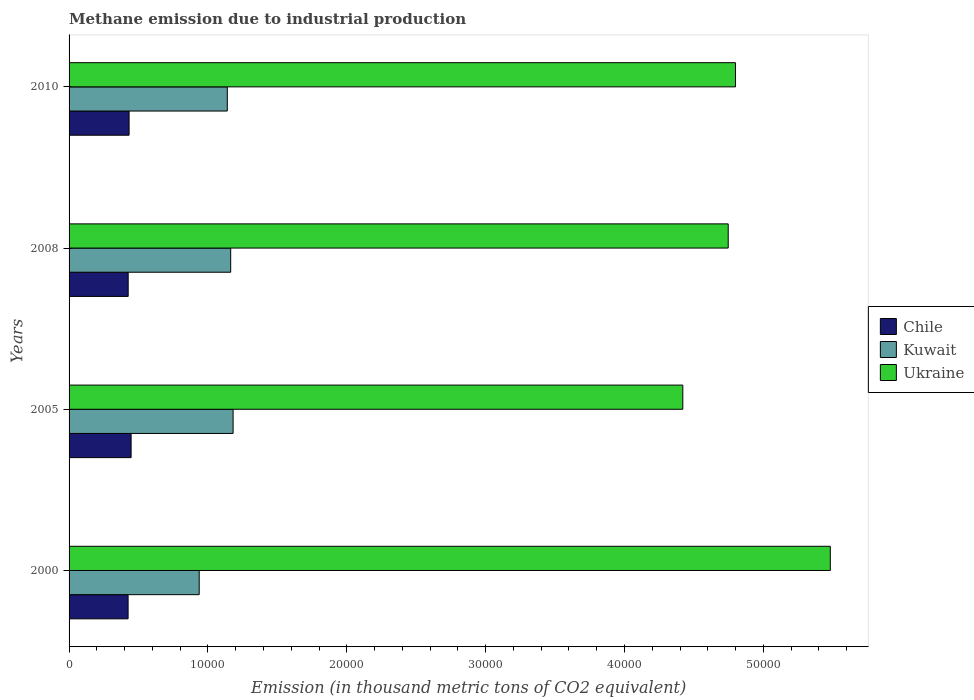How many different coloured bars are there?
Your response must be concise. 3. Are the number of bars per tick equal to the number of legend labels?
Ensure brevity in your answer.  Yes. How many bars are there on the 2nd tick from the top?
Your answer should be compact. 3. How many bars are there on the 2nd tick from the bottom?
Your response must be concise. 3. What is the label of the 4th group of bars from the top?
Offer a very short reply. 2000. In how many cases, is the number of bars for a given year not equal to the number of legend labels?
Offer a very short reply. 0. What is the amount of methane emitted in Ukraine in 2010?
Provide a succinct answer. 4.80e+04. Across all years, what is the maximum amount of methane emitted in Kuwait?
Give a very brief answer. 1.18e+04. Across all years, what is the minimum amount of methane emitted in Chile?
Your response must be concise. 4250.2. What is the total amount of methane emitted in Kuwait in the graph?
Your answer should be compact. 4.42e+04. What is the difference between the amount of methane emitted in Chile in 2005 and that in 2008?
Your response must be concise. 211. What is the difference between the amount of methane emitted in Kuwait in 2000 and the amount of methane emitted in Chile in 2008?
Offer a terse response. 5115. What is the average amount of methane emitted in Chile per year?
Provide a short and direct response. 4324.52. In the year 2010, what is the difference between the amount of methane emitted in Chile and amount of methane emitted in Ukraine?
Offer a very short reply. -4.37e+04. In how many years, is the amount of methane emitted in Chile greater than 48000 thousand metric tons?
Your answer should be very brief. 0. What is the ratio of the amount of methane emitted in Ukraine in 2005 to that in 2008?
Keep it short and to the point. 0.93. What is the difference between the highest and the second highest amount of methane emitted in Chile?
Offer a very short reply. 145.1. What is the difference between the highest and the lowest amount of methane emitted in Kuwait?
Provide a succinct answer. 2439.7. In how many years, is the amount of methane emitted in Ukraine greater than the average amount of methane emitted in Ukraine taken over all years?
Offer a very short reply. 1. Is the sum of the amount of methane emitted in Chile in 2008 and 2010 greater than the maximum amount of methane emitted in Kuwait across all years?
Keep it short and to the point. No. What does the 1st bar from the top in 2000 represents?
Offer a very short reply. Ukraine. What does the 2nd bar from the bottom in 2008 represents?
Ensure brevity in your answer.  Kuwait. Is it the case that in every year, the sum of the amount of methane emitted in Kuwait and amount of methane emitted in Chile is greater than the amount of methane emitted in Ukraine?
Provide a succinct answer. No. Are all the bars in the graph horizontal?
Your answer should be very brief. Yes. What is the difference between two consecutive major ticks on the X-axis?
Ensure brevity in your answer.  10000. Where does the legend appear in the graph?
Your answer should be compact. Center right. How many legend labels are there?
Keep it short and to the point. 3. What is the title of the graph?
Make the answer very short. Methane emission due to industrial production. Does "Tonga" appear as one of the legend labels in the graph?
Provide a succinct answer. No. What is the label or title of the X-axis?
Keep it short and to the point. Emission (in thousand metric tons of CO2 equivalent). What is the Emission (in thousand metric tons of CO2 equivalent) of Chile in 2000?
Your answer should be compact. 4250.2. What is the Emission (in thousand metric tons of CO2 equivalent) in Kuwait in 2000?
Ensure brevity in your answer.  9372. What is the Emission (in thousand metric tons of CO2 equivalent) in Ukraine in 2000?
Offer a very short reply. 5.48e+04. What is the Emission (in thousand metric tons of CO2 equivalent) of Chile in 2005?
Your answer should be very brief. 4468. What is the Emission (in thousand metric tons of CO2 equivalent) in Kuwait in 2005?
Your response must be concise. 1.18e+04. What is the Emission (in thousand metric tons of CO2 equivalent) of Ukraine in 2005?
Offer a terse response. 4.42e+04. What is the Emission (in thousand metric tons of CO2 equivalent) in Chile in 2008?
Give a very brief answer. 4257. What is the Emission (in thousand metric tons of CO2 equivalent) in Kuwait in 2008?
Offer a terse response. 1.16e+04. What is the Emission (in thousand metric tons of CO2 equivalent) in Ukraine in 2008?
Your answer should be compact. 4.75e+04. What is the Emission (in thousand metric tons of CO2 equivalent) of Chile in 2010?
Your answer should be compact. 4322.9. What is the Emission (in thousand metric tons of CO2 equivalent) in Kuwait in 2010?
Your response must be concise. 1.14e+04. What is the Emission (in thousand metric tons of CO2 equivalent) of Ukraine in 2010?
Your answer should be very brief. 4.80e+04. Across all years, what is the maximum Emission (in thousand metric tons of CO2 equivalent) in Chile?
Offer a terse response. 4468. Across all years, what is the maximum Emission (in thousand metric tons of CO2 equivalent) in Kuwait?
Give a very brief answer. 1.18e+04. Across all years, what is the maximum Emission (in thousand metric tons of CO2 equivalent) of Ukraine?
Keep it short and to the point. 5.48e+04. Across all years, what is the minimum Emission (in thousand metric tons of CO2 equivalent) of Chile?
Make the answer very short. 4250.2. Across all years, what is the minimum Emission (in thousand metric tons of CO2 equivalent) of Kuwait?
Provide a succinct answer. 9372. Across all years, what is the minimum Emission (in thousand metric tons of CO2 equivalent) of Ukraine?
Provide a short and direct response. 4.42e+04. What is the total Emission (in thousand metric tons of CO2 equivalent) of Chile in the graph?
Ensure brevity in your answer.  1.73e+04. What is the total Emission (in thousand metric tons of CO2 equivalent) in Kuwait in the graph?
Provide a short and direct response. 4.42e+04. What is the total Emission (in thousand metric tons of CO2 equivalent) in Ukraine in the graph?
Make the answer very short. 1.94e+05. What is the difference between the Emission (in thousand metric tons of CO2 equivalent) in Chile in 2000 and that in 2005?
Provide a short and direct response. -217.8. What is the difference between the Emission (in thousand metric tons of CO2 equivalent) of Kuwait in 2000 and that in 2005?
Give a very brief answer. -2439.7. What is the difference between the Emission (in thousand metric tons of CO2 equivalent) of Ukraine in 2000 and that in 2005?
Your answer should be compact. 1.06e+04. What is the difference between the Emission (in thousand metric tons of CO2 equivalent) of Chile in 2000 and that in 2008?
Give a very brief answer. -6.8. What is the difference between the Emission (in thousand metric tons of CO2 equivalent) in Kuwait in 2000 and that in 2008?
Give a very brief answer. -2266.8. What is the difference between the Emission (in thousand metric tons of CO2 equivalent) in Ukraine in 2000 and that in 2008?
Provide a succinct answer. 7351.3. What is the difference between the Emission (in thousand metric tons of CO2 equivalent) of Chile in 2000 and that in 2010?
Keep it short and to the point. -72.7. What is the difference between the Emission (in thousand metric tons of CO2 equivalent) in Kuwait in 2000 and that in 2010?
Keep it short and to the point. -2022.2. What is the difference between the Emission (in thousand metric tons of CO2 equivalent) of Ukraine in 2000 and that in 2010?
Ensure brevity in your answer.  6827. What is the difference between the Emission (in thousand metric tons of CO2 equivalent) in Chile in 2005 and that in 2008?
Your answer should be very brief. 211. What is the difference between the Emission (in thousand metric tons of CO2 equivalent) of Kuwait in 2005 and that in 2008?
Make the answer very short. 172.9. What is the difference between the Emission (in thousand metric tons of CO2 equivalent) in Ukraine in 2005 and that in 2008?
Provide a succinct answer. -3269.3. What is the difference between the Emission (in thousand metric tons of CO2 equivalent) of Chile in 2005 and that in 2010?
Provide a succinct answer. 145.1. What is the difference between the Emission (in thousand metric tons of CO2 equivalent) of Kuwait in 2005 and that in 2010?
Give a very brief answer. 417.5. What is the difference between the Emission (in thousand metric tons of CO2 equivalent) of Ukraine in 2005 and that in 2010?
Your answer should be very brief. -3793.6. What is the difference between the Emission (in thousand metric tons of CO2 equivalent) in Chile in 2008 and that in 2010?
Make the answer very short. -65.9. What is the difference between the Emission (in thousand metric tons of CO2 equivalent) in Kuwait in 2008 and that in 2010?
Provide a short and direct response. 244.6. What is the difference between the Emission (in thousand metric tons of CO2 equivalent) in Ukraine in 2008 and that in 2010?
Give a very brief answer. -524.3. What is the difference between the Emission (in thousand metric tons of CO2 equivalent) of Chile in 2000 and the Emission (in thousand metric tons of CO2 equivalent) of Kuwait in 2005?
Offer a very short reply. -7561.5. What is the difference between the Emission (in thousand metric tons of CO2 equivalent) of Chile in 2000 and the Emission (in thousand metric tons of CO2 equivalent) of Ukraine in 2005?
Provide a short and direct response. -3.99e+04. What is the difference between the Emission (in thousand metric tons of CO2 equivalent) in Kuwait in 2000 and the Emission (in thousand metric tons of CO2 equivalent) in Ukraine in 2005?
Make the answer very short. -3.48e+04. What is the difference between the Emission (in thousand metric tons of CO2 equivalent) in Chile in 2000 and the Emission (in thousand metric tons of CO2 equivalent) in Kuwait in 2008?
Ensure brevity in your answer.  -7388.6. What is the difference between the Emission (in thousand metric tons of CO2 equivalent) in Chile in 2000 and the Emission (in thousand metric tons of CO2 equivalent) in Ukraine in 2008?
Your response must be concise. -4.32e+04. What is the difference between the Emission (in thousand metric tons of CO2 equivalent) in Kuwait in 2000 and the Emission (in thousand metric tons of CO2 equivalent) in Ukraine in 2008?
Keep it short and to the point. -3.81e+04. What is the difference between the Emission (in thousand metric tons of CO2 equivalent) of Chile in 2000 and the Emission (in thousand metric tons of CO2 equivalent) of Kuwait in 2010?
Keep it short and to the point. -7144. What is the difference between the Emission (in thousand metric tons of CO2 equivalent) of Chile in 2000 and the Emission (in thousand metric tons of CO2 equivalent) of Ukraine in 2010?
Make the answer very short. -4.37e+04. What is the difference between the Emission (in thousand metric tons of CO2 equivalent) of Kuwait in 2000 and the Emission (in thousand metric tons of CO2 equivalent) of Ukraine in 2010?
Make the answer very short. -3.86e+04. What is the difference between the Emission (in thousand metric tons of CO2 equivalent) of Chile in 2005 and the Emission (in thousand metric tons of CO2 equivalent) of Kuwait in 2008?
Provide a succinct answer. -7170.8. What is the difference between the Emission (in thousand metric tons of CO2 equivalent) of Chile in 2005 and the Emission (in thousand metric tons of CO2 equivalent) of Ukraine in 2008?
Make the answer very short. -4.30e+04. What is the difference between the Emission (in thousand metric tons of CO2 equivalent) of Kuwait in 2005 and the Emission (in thousand metric tons of CO2 equivalent) of Ukraine in 2008?
Your answer should be compact. -3.57e+04. What is the difference between the Emission (in thousand metric tons of CO2 equivalent) in Chile in 2005 and the Emission (in thousand metric tons of CO2 equivalent) in Kuwait in 2010?
Offer a very short reply. -6926.2. What is the difference between the Emission (in thousand metric tons of CO2 equivalent) in Chile in 2005 and the Emission (in thousand metric tons of CO2 equivalent) in Ukraine in 2010?
Your response must be concise. -4.35e+04. What is the difference between the Emission (in thousand metric tons of CO2 equivalent) in Kuwait in 2005 and the Emission (in thousand metric tons of CO2 equivalent) in Ukraine in 2010?
Your answer should be compact. -3.62e+04. What is the difference between the Emission (in thousand metric tons of CO2 equivalent) in Chile in 2008 and the Emission (in thousand metric tons of CO2 equivalent) in Kuwait in 2010?
Ensure brevity in your answer.  -7137.2. What is the difference between the Emission (in thousand metric tons of CO2 equivalent) in Chile in 2008 and the Emission (in thousand metric tons of CO2 equivalent) in Ukraine in 2010?
Provide a short and direct response. -4.37e+04. What is the difference between the Emission (in thousand metric tons of CO2 equivalent) of Kuwait in 2008 and the Emission (in thousand metric tons of CO2 equivalent) of Ukraine in 2010?
Give a very brief answer. -3.64e+04. What is the average Emission (in thousand metric tons of CO2 equivalent) of Chile per year?
Keep it short and to the point. 4324.52. What is the average Emission (in thousand metric tons of CO2 equivalent) of Kuwait per year?
Offer a very short reply. 1.11e+04. What is the average Emission (in thousand metric tons of CO2 equivalent) of Ukraine per year?
Offer a terse response. 4.86e+04. In the year 2000, what is the difference between the Emission (in thousand metric tons of CO2 equivalent) of Chile and Emission (in thousand metric tons of CO2 equivalent) of Kuwait?
Your answer should be very brief. -5121.8. In the year 2000, what is the difference between the Emission (in thousand metric tons of CO2 equivalent) in Chile and Emission (in thousand metric tons of CO2 equivalent) in Ukraine?
Your answer should be very brief. -5.06e+04. In the year 2000, what is the difference between the Emission (in thousand metric tons of CO2 equivalent) of Kuwait and Emission (in thousand metric tons of CO2 equivalent) of Ukraine?
Offer a very short reply. -4.54e+04. In the year 2005, what is the difference between the Emission (in thousand metric tons of CO2 equivalent) in Chile and Emission (in thousand metric tons of CO2 equivalent) in Kuwait?
Provide a short and direct response. -7343.7. In the year 2005, what is the difference between the Emission (in thousand metric tons of CO2 equivalent) of Chile and Emission (in thousand metric tons of CO2 equivalent) of Ukraine?
Offer a terse response. -3.97e+04. In the year 2005, what is the difference between the Emission (in thousand metric tons of CO2 equivalent) of Kuwait and Emission (in thousand metric tons of CO2 equivalent) of Ukraine?
Ensure brevity in your answer.  -3.24e+04. In the year 2008, what is the difference between the Emission (in thousand metric tons of CO2 equivalent) of Chile and Emission (in thousand metric tons of CO2 equivalent) of Kuwait?
Offer a very short reply. -7381.8. In the year 2008, what is the difference between the Emission (in thousand metric tons of CO2 equivalent) of Chile and Emission (in thousand metric tons of CO2 equivalent) of Ukraine?
Your response must be concise. -4.32e+04. In the year 2008, what is the difference between the Emission (in thousand metric tons of CO2 equivalent) of Kuwait and Emission (in thousand metric tons of CO2 equivalent) of Ukraine?
Make the answer very short. -3.58e+04. In the year 2010, what is the difference between the Emission (in thousand metric tons of CO2 equivalent) of Chile and Emission (in thousand metric tons of CO2 equivalent) of Kuwait?
Keep it short and to the point. -7071.3. In the year 2010, what is the difference between the Emission (in thousand metric tons of CO2 equivalent) in Chile and Emission (in thousand metric tons of CO2 equivalent) in Ukraine?
Provide a succinct answer. -4.37e+04. In the year 2010, what is the difference between the Emission (in thousand metric tons of CO2 equivalent) of Kuwait and Emission (in thousand metric tons of CO2 equivalent) of Ukraine?
Keep it short and to the point. -3.66e+04. What is the ratio of the Emission (in thousand metric tons of CO2 equivalent) in Chile in 2000 to that in 2005?
Provide a succinct answer. 0.95. What is the ratio of the Emission (in thousand metric tons of CO2 equivalent) of Kuwait in 2000 to that in 2005?
Make the answer very short. 0.79. What is the ratio of the Emission (in thousand metric tons of CO2 equivalent) in Ukraine in 2000 to that in 2005?
Keep it short and to the point. 1.24. What is the ratio of the Emission (in thousand metric tons of CO2 equivalent) in Chile in 2000 to that in 2008?
Ensure brevity in your answer.  1. What is the ratio of the Emission (in thousand metric tons of CO2 equivalent) in Kuwait in 2000 to that in 2008?
Your answer should be compact. 0.81. What is the ratio of the Emission (in thousand metric tons of CO2 equivalent) of Ukraine in 2000 to that in 2008?
Your answer should be compact. 1.15. What is the ratio of the Emission (in thousand metric tons of CO2 equivalent) of Chile in 2000 to that in 2010?
Keep it short and to the point. 0.98. What is the ratio of the Emission (in thousand metric tons of CO2 equivalent) of Kuwait in 2000 to that in 2010?
Offer a very short reply. 0.82. What is the ratio of the Emission (in thousand metric tons of CO2 equivalent) of Ukraine in 2000 to that in 2010?
Provide a succinct answer. 1.14. What is the ratio of the Emission (in thousand metric tons of CO2 equivalent) of Chile in 2005 to that in 2008?
Make the answer very short. 1.05. What is the ratio of the Emission (in thousand metric tons of CO2 equivalent) of Kuwait in 2005 to that in 2008?
Keep it short and to the point. 1.01. What is the ratio of the Emission (in thousand metric tons of CO2 equivalent) in Ukraine in 2005 to that in 2008?
Offer a very short reply. 0.93. What is the ratio of the Emission (in thousand metric tons of CO2 equivalent) in Chile in 2005 to that in 2010?
Make the answer very short. 1.03. What is the ratio of the Emission (in thousand metric tons of CO2 equivalent) of Kuwait in 2005 to that in 2010?
Make the answer very short. 1.04. What is the ratio of the Emission (in thousand metric tons of CO2 equivalent) in Ukraine in 2005 to that in 2010?
Provide a succinct answer. 0.92. What is the ratio of the Emission (in thousand metric tons of CO2 equivalent) in Kuwait in 2008 to that in 2010?
Ensure brevity in your answer.  1.02. What is the difference between the highest and the second highest Emission (in thousand metric tons of CO2 equivalent) in Chile?
Keep it short and to the point. 145.1. What is the difference between the highest and the second highest Emission (in thousand metric tons of CO2 equivalent) in Kuwait?
Ensure brevity in your answer.  172.9. What is the difference between the highest and the second highest Emission (in thousand metric tons of CO2 equivalent) of Ukraine?
Provide a short and direct response. 6827. What is the difference between the highest and the lowest Emission (in thousand metric tons of CO2 equivalent) of Chile?
Your answer should be compact. 217.8. What is the difference between the highest and the lowest Emission (in thousand metric tons of CO2 equivalent) in Kuwait?
Provide a short and direct response. 2439.7. What is the difference between the highest and the lowest Emission (in thousand metric tons of CO2 equivalent) in Ukraine?
Ensure brevity in your answer.  1.06e+04. 